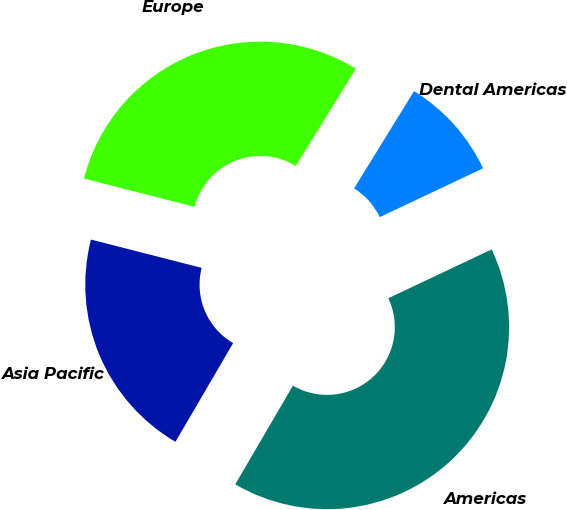Convert chart. <chart><loc_0><loc_0><loc_500><loc_500><pie_chart><fcel>Europe<fcel>Asia Pacific<fcel>Americas<fcel>Dental Americas<nl><fcel>29.81%<fcel>20.57%<fcel>40.44%<fcel>9.18%<nl></chart> 